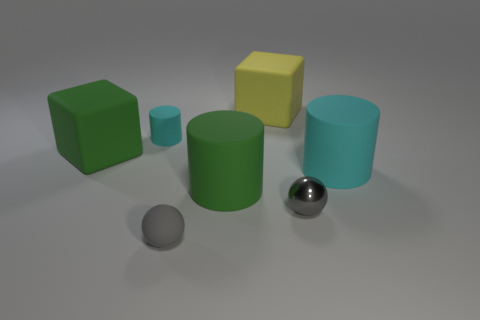The tiny sphere that is right of the yellow block behind the big green matte cube is made of what material?
Your answer should be very brief. Metal. What number of small gray metal objects have the same shape as the yellow object?
Provide a short and direct response. 0. There is a gray shiny thing; what shape is it?
Give a very brief answer. Sphere. Are there fewer gray cubes than blocks?
Provide a short and direct response. Yes. Is there anything else that has the same size as the gray metal ball?
Provide a succinct answer. Yes. There is another thing that is the same shape as the yellow object; what material is it?
Your response must be concise. Rubber. Is the number of small gray metal balls greater than the number of red shiny balls?
Ensure brevity in your answer.  Yes. What number of other things are there of the same color as the tiny metallic ball?
Offer a very short reply. 1. Are the tiny cyan object and the gray thing on the right side of the big yellow rubber object made of the same material?
Make the answer very short. No. There is a small thing left of the tiny gray thing left of the tiny gray metallic object; what number of big green rubber cylinders are left of it?
Provide a short and direct response. 0. 